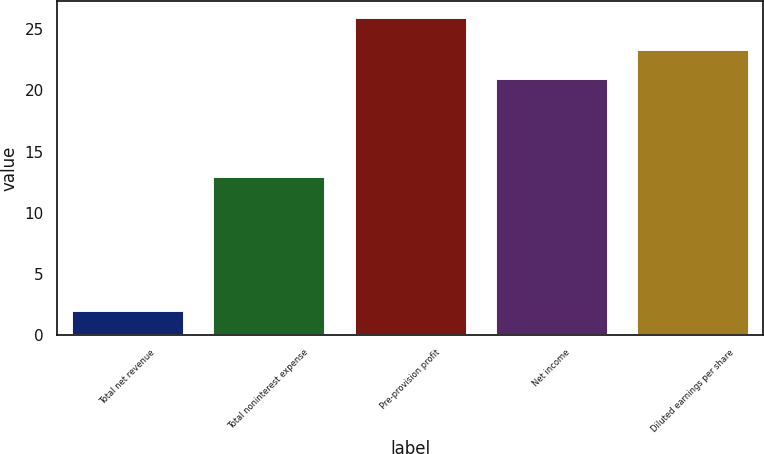Convert chart to OTSL. <chart><loc_0><loc_0><loc_500><loc_500><bar_chart><fcel>Total net revenue<fcel>Total noninterest expense<fcel>Pre-provision profit<fcel>Net income<fcel>Diluted earnings per share<nl><fcel>2<fcel>13<fcel>26<fcel>21<fcel>23.4<nl></chart> 